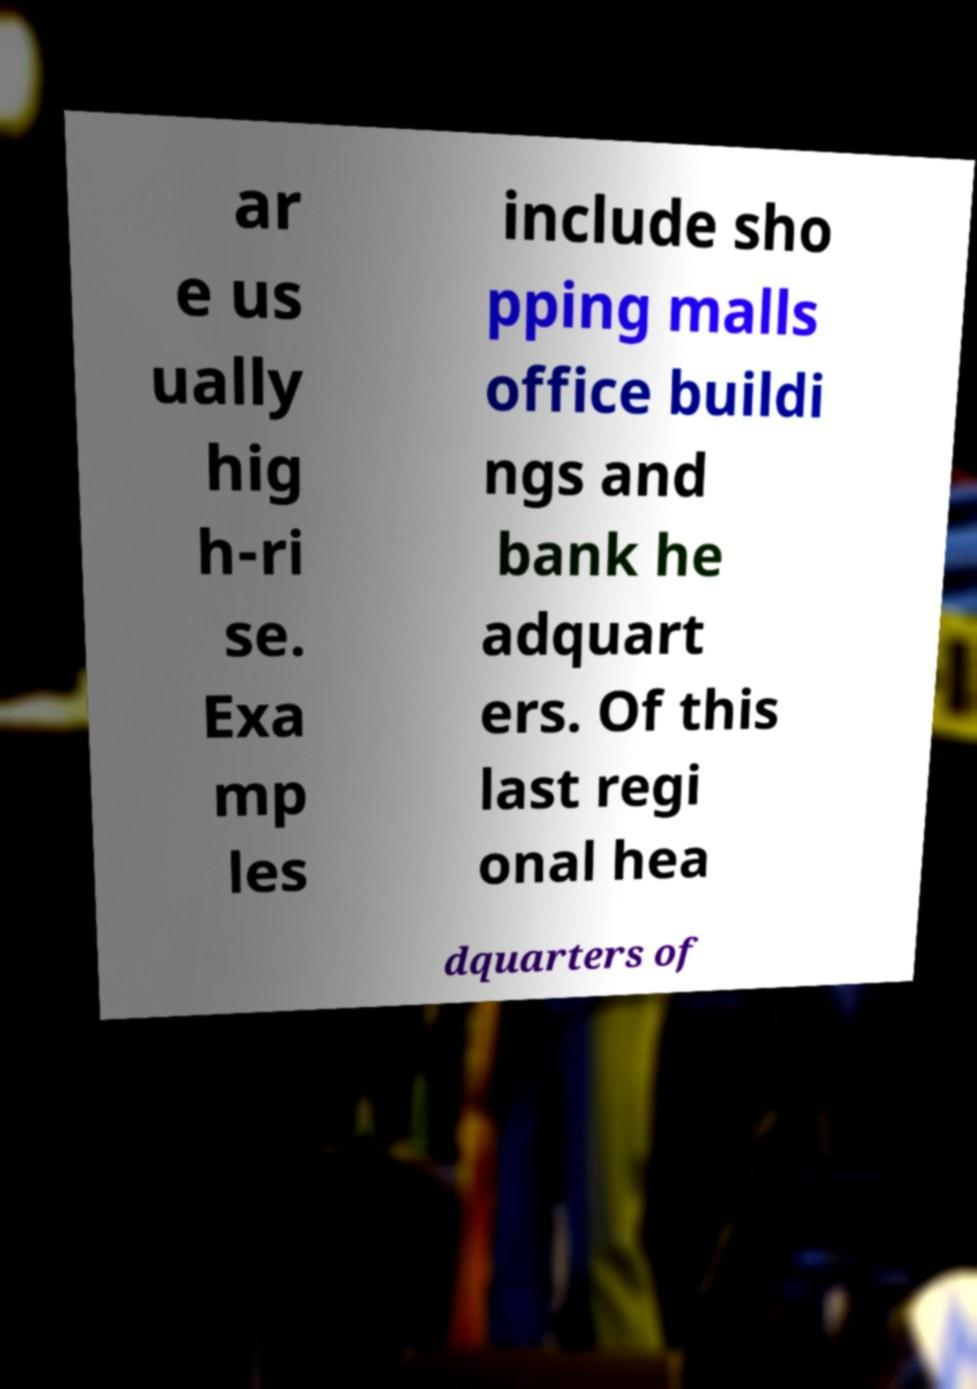I need the written content from this picture converted into text. Can you do that? ar e us ually hig h-ri se. Exa mp les include sho pping malls office buildi ngs and bank he adquart ers. Of this last regi onal hea dquarters of 